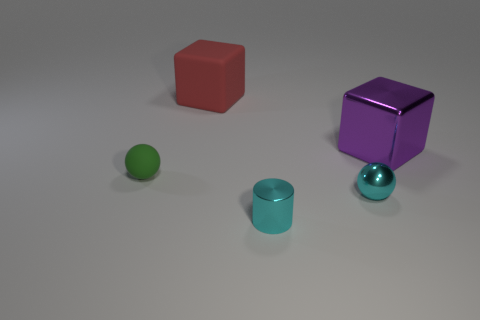Add 1 metallic objects. How many objects exist? 6 Subtract all balls. How many objects are left? 3 Subtract 1 green balls. How many objects are left? 4 Subtract all blue cylinders. Subtract all small green matte objects. How many objects are left? 4 Add 1 cylinders. How many cylinders are left? 2 Add 1 big balls. How many big balls exist? 1 